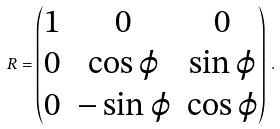Convert formula to latex. <formula><loc_0><loc_0><loc_500><loc_500>R = \begin{pmatrix} 1 & 0 & 0 \\ 0 & \cos \varphi & \sin \varphi \\ 0 & - \sin \varphi & \cos \varphi \end{pmatrix} \, .</formula> 